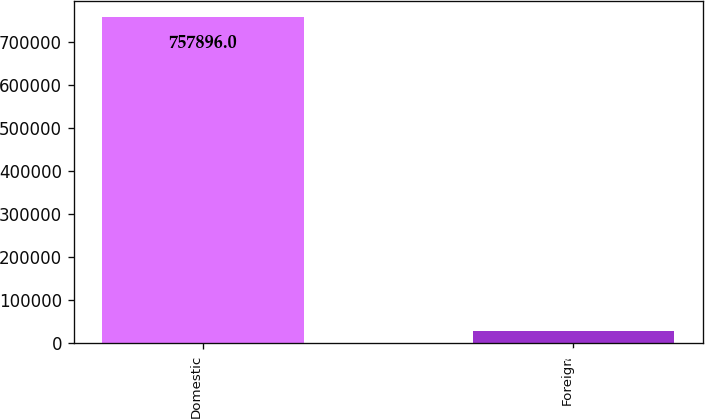<chart> <loc_0><loc_0><loc_500><loc_500><bar_chart><fcel>Domestic<fcel>Foreign<nl><fcel>757896<fcel>29538<nl></chart> 